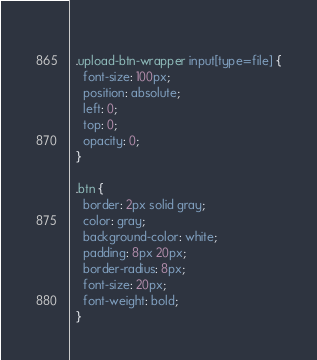Convert code to text. <code><loc_0><loc_0><loc_500><loc_500><_CSS_>  
  .upload-btn-wrapper input[type=file] {
    font-size: 100px;
    position: absolute;
    left: 0;
    top: 0;
    opacity: 0;
  }

  .btn {
    border: 2px solid gray;
    color: gray;
    background-color: white;
    padding: 8px 20px;
    border-radius: 8px;
    font-size: 20px;
    font-weight: bold;
  }</code> 